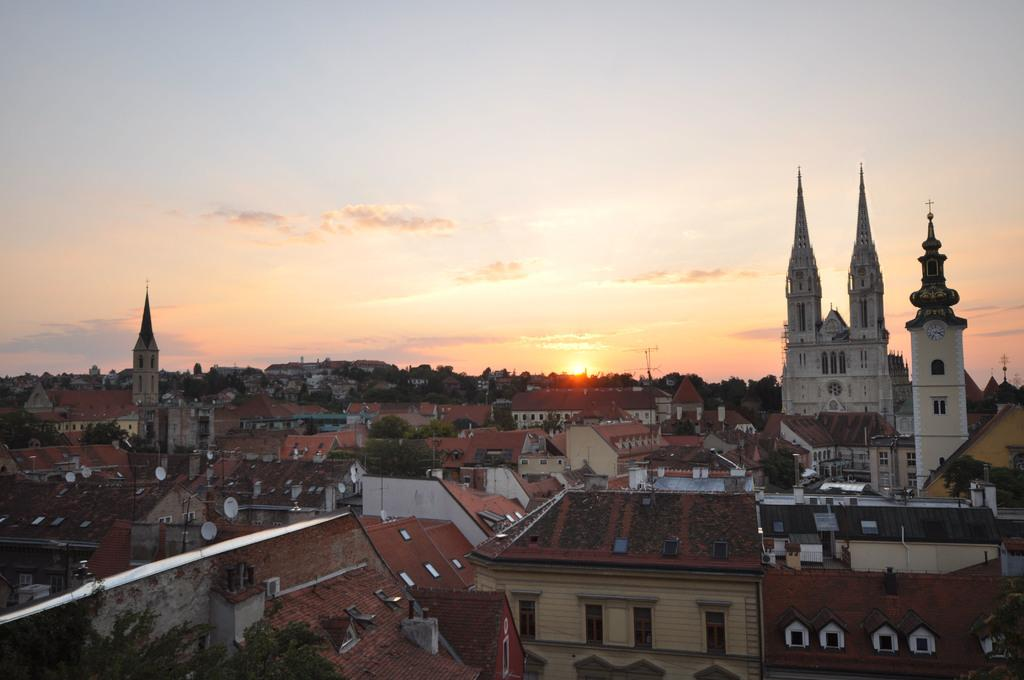What type of buildings can be seen in the image? There are houses and churches in the image. What is located between the houses? Trees are present between the houses. What natural phenomenon is visible in the background of the image? There is a sunrise visible in the background of the image. What type of shirt is the sun wearing in the image? The sun is not wearing a shirt in the image, as it is a celestial body and not a person. 